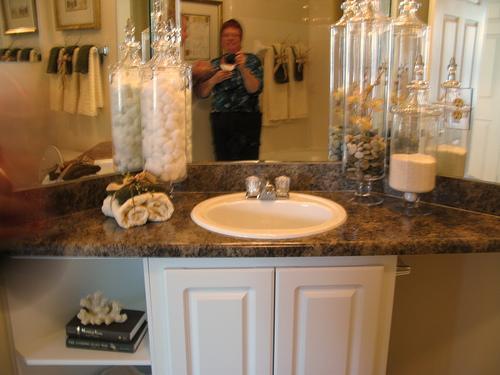How many women are there?
Give a very brief answer. 1. How many books are in the room?
Give a very brief answer. 2. How many vases are in the picture?
Give a very brief answer. 5. 